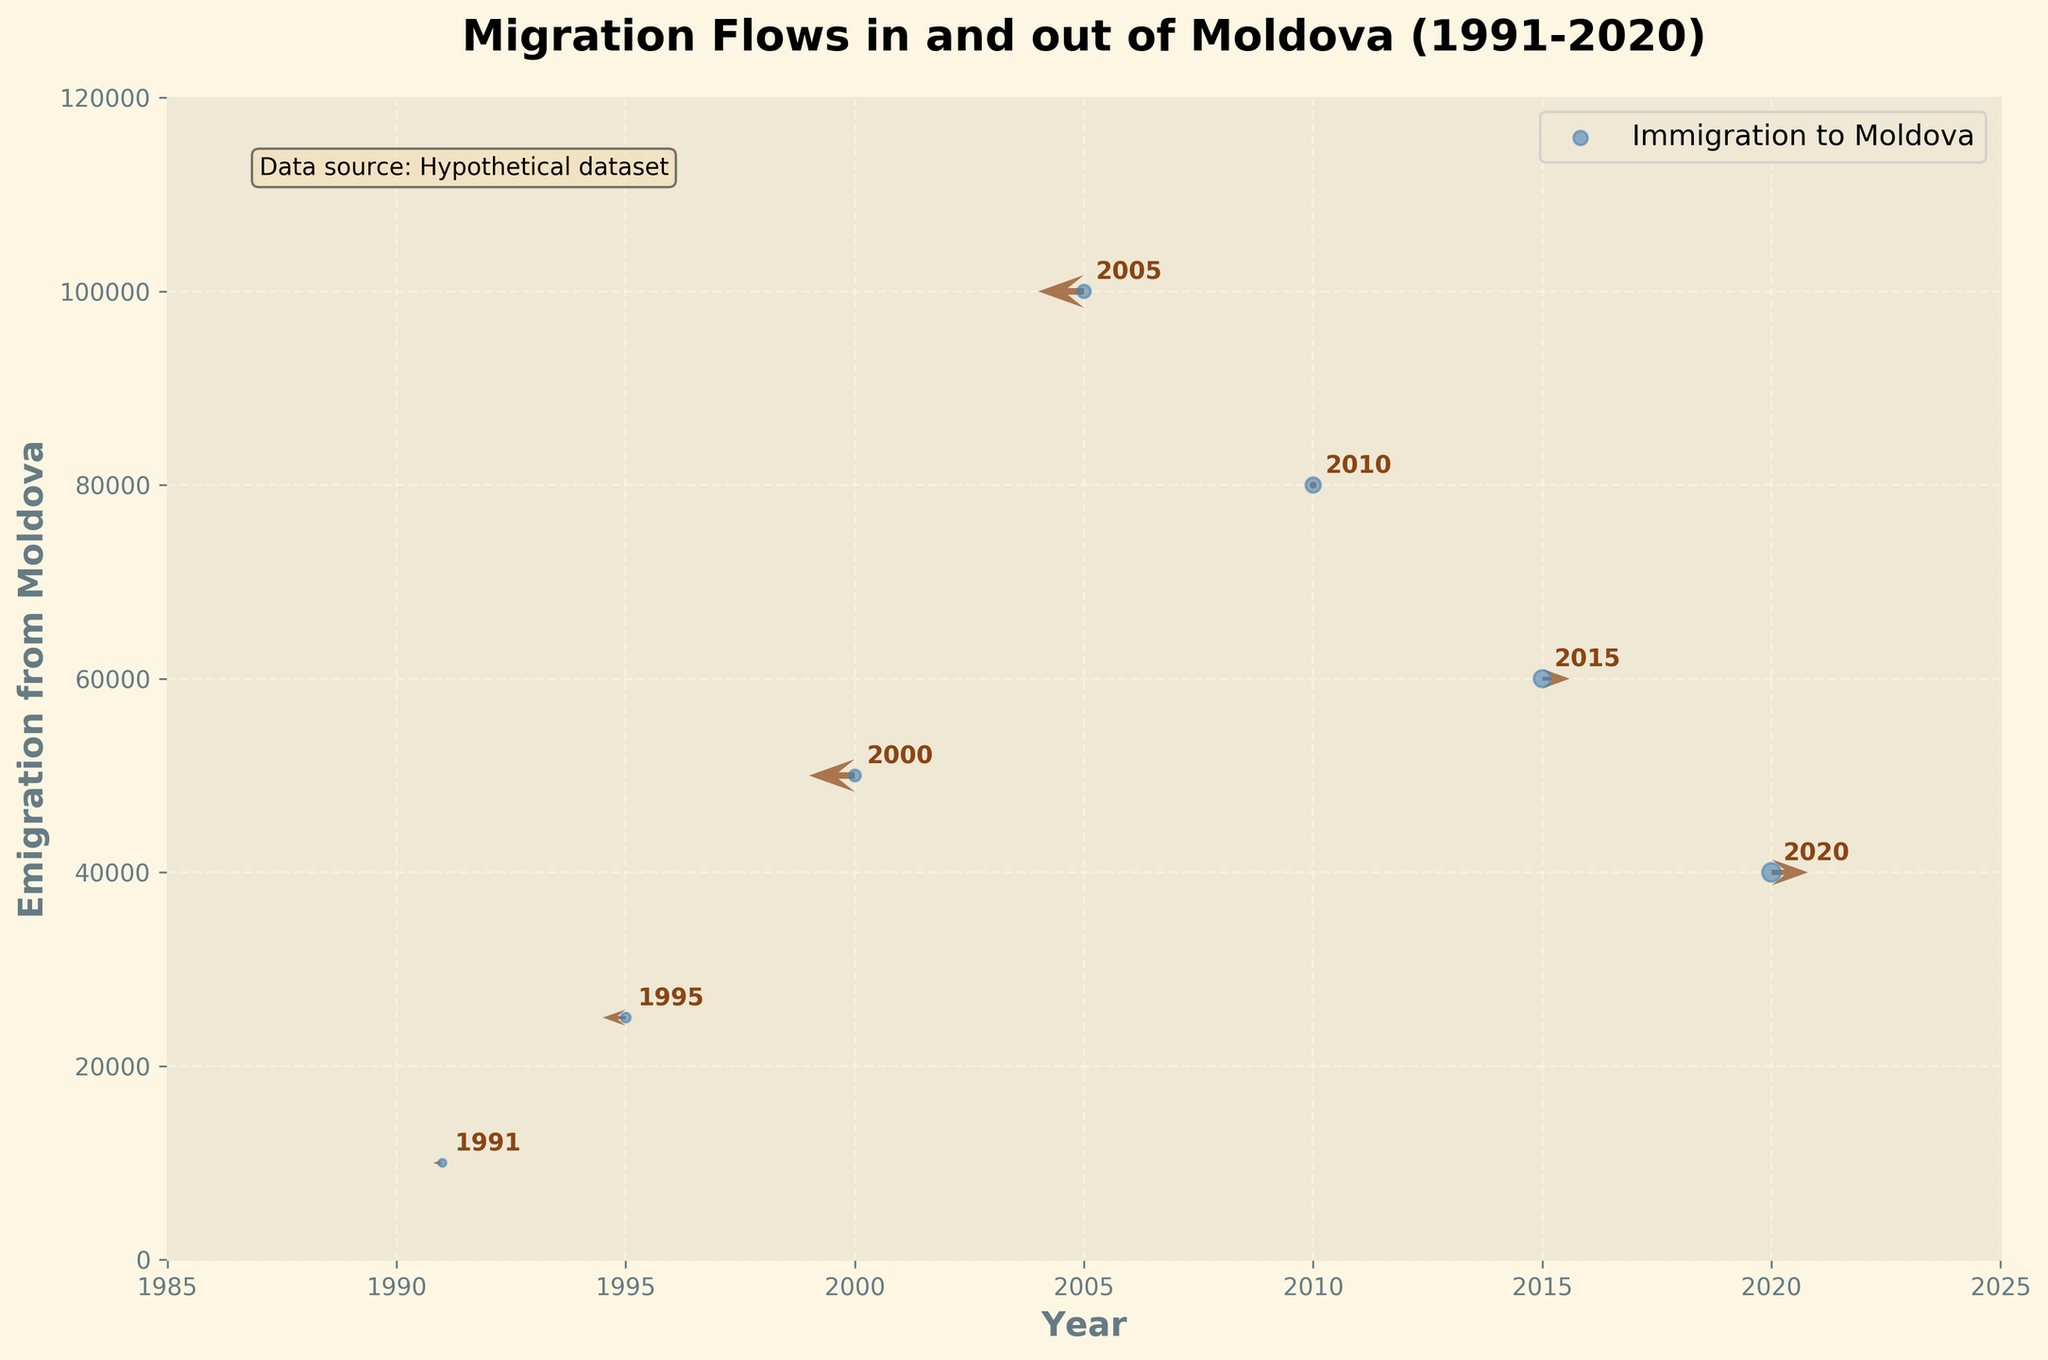How many data points are there in the figure? There are seven years represented in the figure: 1991, 1995, 2000, 2005, 2010, 2015, and 2020. Each year corresponds to one data point.
Answer: 7 What is the title of the figure? The title of the figure is prominently displayed at the top.
Answer: Migration Flows in and out of Moldova (1991-2020) Which year had the highest emigration from Moldova? By examining the y-axis values for "Emigration from Moldova," the highest value occurs in 2005 with 100,000 emigrants.
Answer: 2005 Which year had the lowest immigration to Moldova? By looking at the size of the scatter points, the smallest one corresponds to 1991 with 5,000 immigrants.
Answer: 1991 How does the direction of migration change over the years? The directions (arrows) change from pointing left (negative x direction) in early years to pointing right (positive x direction) in later years, with some variation in the middle years.
Answer: From negative to positive x direction What's the average number of emigrants from Moldova over the given years? Sum the emigration values: 10,000 + 25,000 + 50,000 + 100,000 + 80,000 + 60,000 + 40,000 = 365,000. Divide by the number of years: 365,000 / 7 ≈ 52,143.
Answer: 52,143 Which year had equal numbers of emigrants and immigrants? The closest year to having equal numbers is 2020, given the visual comparison of the y-values and size of scatter points.
Answer: 2020 What is the direction vector for the year 2000? The year 2000 has a direction vector that points downwards and to the left.
Answer: (-1, -1) How does the magnitude of the immigration flows compare between 2010 and 2015? By comparing the scatter point sizes, 2015 has a larger point than 2010, indicating more immigrants in 2015 than in 2010.
Answer: 2015 has more immigrants than 2010 Does the figure indicate a general trend of increasing or decreasing emigration over time? The y-axis shows the emigration values decrease from a peak in 2005 to 40,000 in 2020, indicating a decreasing trend over time.
Answer: Decreasing trend 